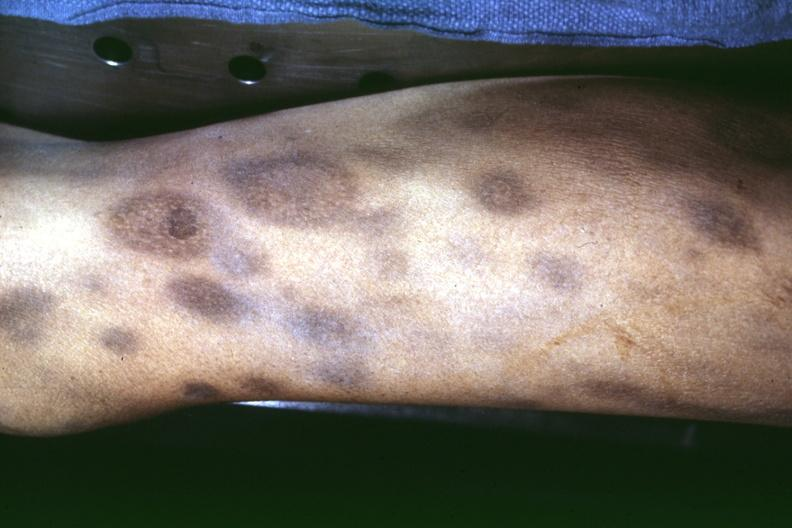what does this image show?
Answer the question using a single word or phrase. External view of knee at autopsy ecchymoses with necrotic appearing centers looks like pyoderma gangrenosum 